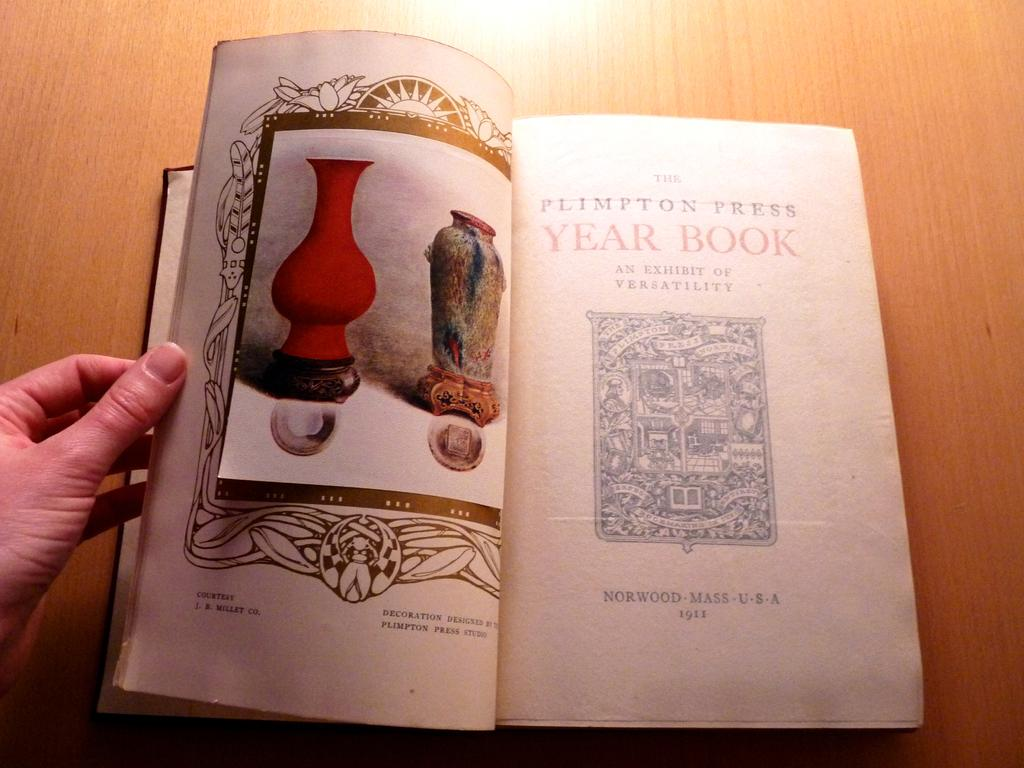<image>
Offer a succinct explanation of the picture presented. The Plimpton Press Yearbook is open on the table. 